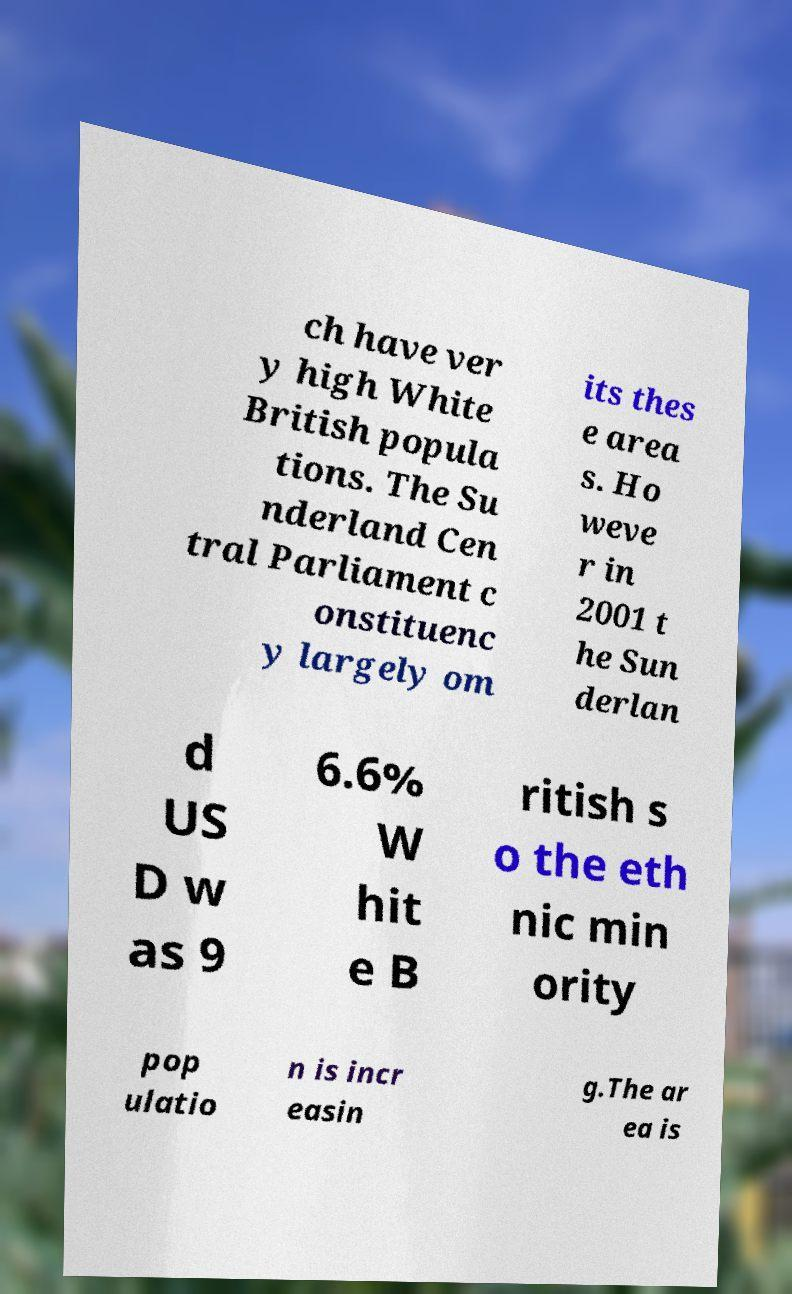Can you read and provide the text displayed in the image?This photo seems to have some interesting text. Can you extract and type it out for me? ch have ver y high White British popula tions. The Su nderland Cen tral Parliament c onstituenc y largely om its thes e area s. Ho weve r in 2001 t he Sun derlan d US D w as 9 6.6% W hit e B ritish s o the eth nic min ority pop ulatio n is incr easin g.The ar ea is 